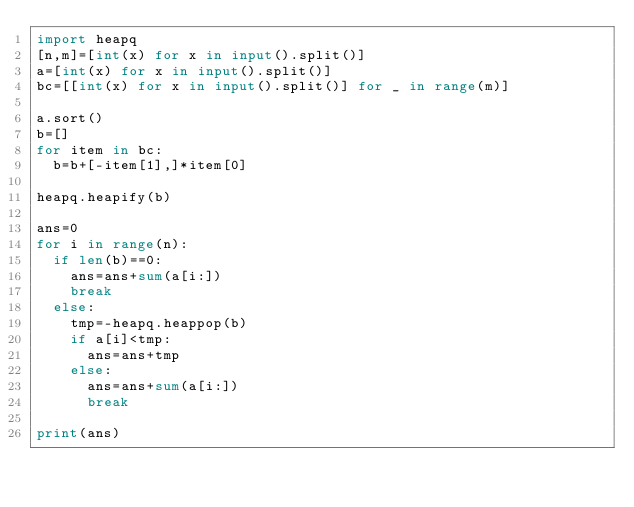<code> <loc_0><loc_0><loc_500><loc_500><_Python_>import heapq
[n,m]=[int(x) for x in input().split()]
a=[int(x) for x in input().split()]
bc=[[int(x) for x in input().split()] for _ in range(m)]

a.sort()
b=[]
for item in bc:
  b=b+[-item[1],]*item[0]

heapq.heapify(b) 

ans=0
for i in range(n):
  if len(b)==0:
    ans=ans+sum(a[i:])
    break
  else:
    tmp=-heapq.heappop(b)
    if a[i]<tmp:
      ans=ans+tmp
    else:
      ans=ans+sum(a[i:])
      break

print(ans)
</code> 